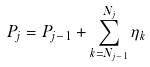<formula> <loc_0><loc_0><loc_500><loc_500>P _ { j } = P _ { j - 1 } + \sum _ { k = N _ { j - 1 } } ^ { N _ { j } } \eta _ { k }</formula> 